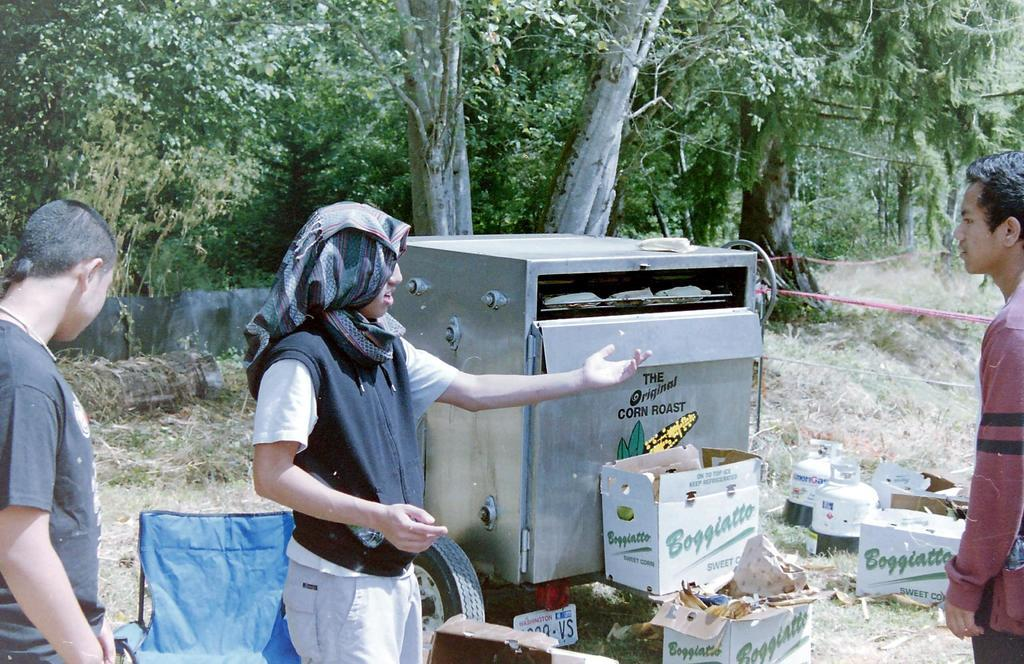How many people are present in the image? There are three people in the image. What is one person wearing on their head? One person is wearing cloth on their head. What type of natural elements can be seen in the image? There are trees and plants in the image. What man-made objects can be seen in the image? There are boxes and a machine in the image. What type of fork is being used by the person wearing cloth on their head in the image? There is no fork present in the image; the person is wearing cloth on their head. What achievement has the person wearing cloth on their head accomplished, as depicted in the image? The image does not provide information about any achievements or accomplishments of the person wearing cloth on their head. 